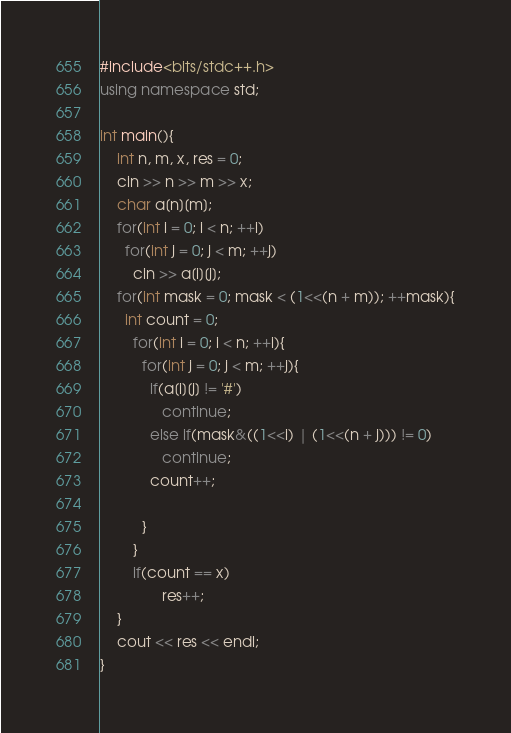Convert code to text. <code><loc_0><loc_0><loc_500><loc_500><_C++_>#include<bits/stdc++.h>
using namespace std;

int main(){
	int n, m, x, res = 0;
  	cin >> n >> m >> x;
  	char a[n][m];
  	for(int i = 0; i < n; ++i)
      for(int j = 0; j < m; ++j)
        cin >> a[i][j];
  	for(int mask = 0; mask < (1<<(n + m)); ++mask){
      int count = 0;
    	for(int i = 0; i < n; ++i){
          for(int j = 0; j < m; ++j){
         	if(a[i][j] != '#')
               continue;
            else if(mask&((1<<i) | (1<<(n + j))) != 0)
               continue;
           	count++;
				
          }
        }
        if(count == x)
               res++;
    }
    cout << res << endl;
}
</code> 